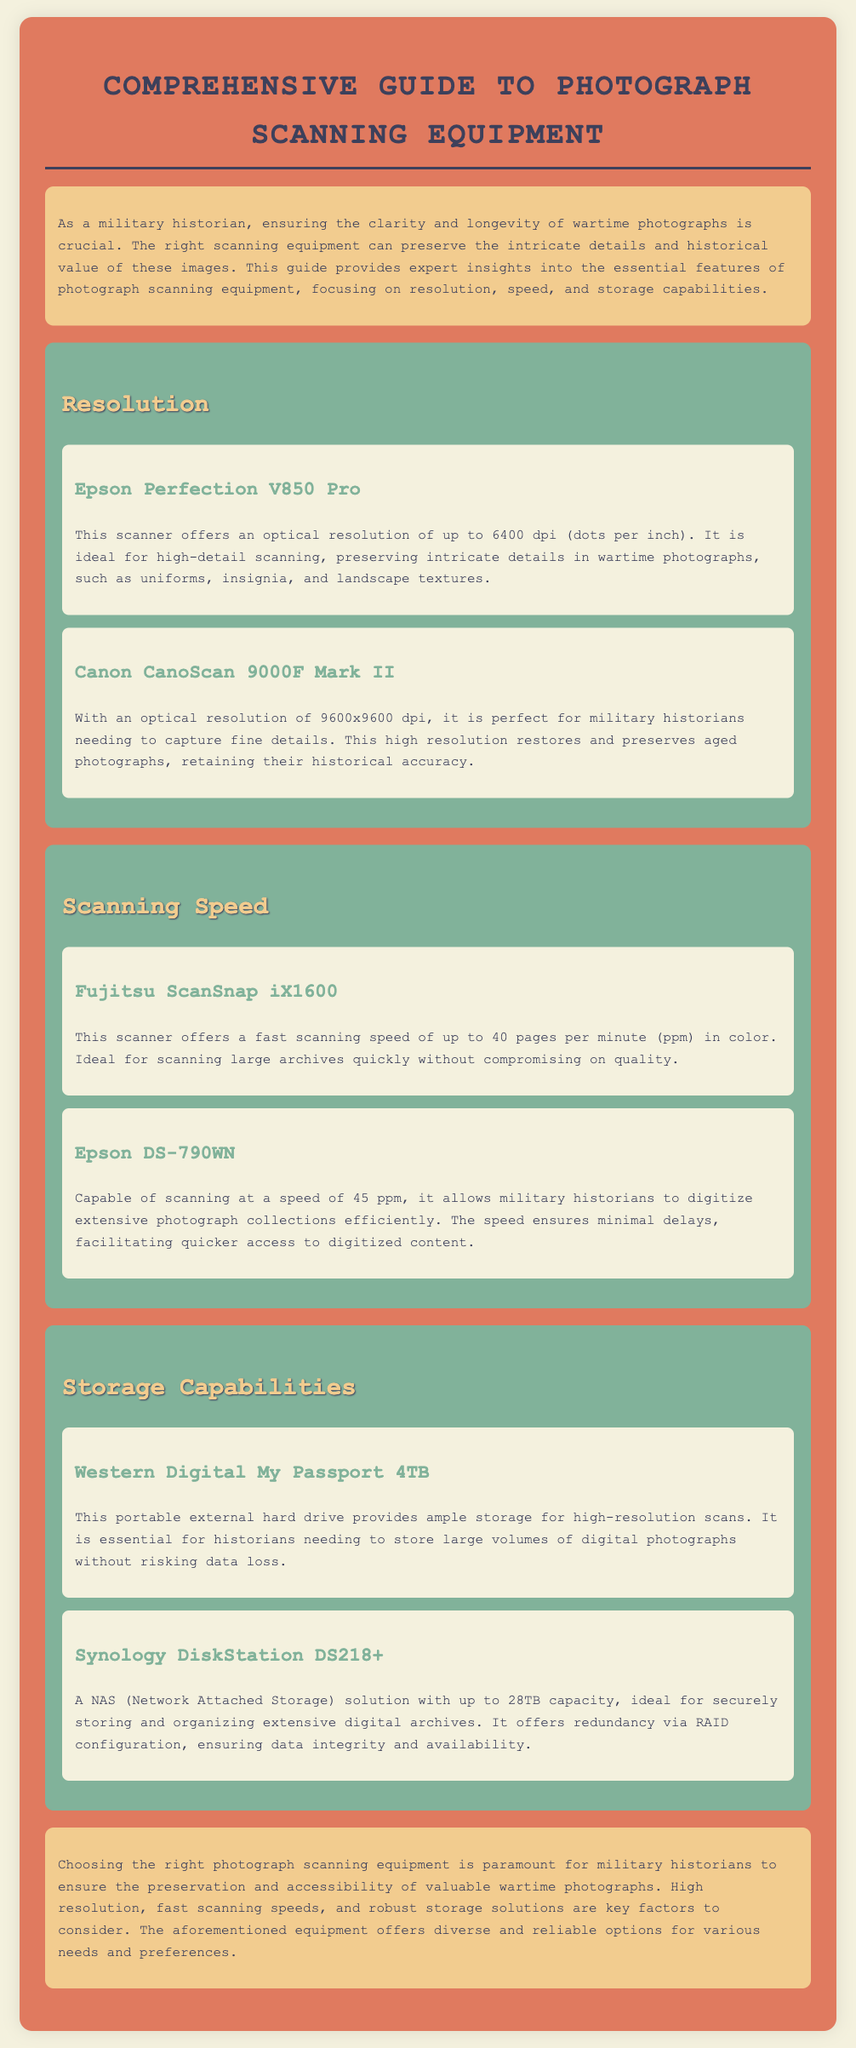What is the optical resolution of the Epson Perfection V850 Pro? The optical resolution is noted as up to 6400 dpi in the document.
Answer: 6400 dpi What is the scanning speed of the Epson DS-790WN? The document states that the Epson DS-790WN scans at a speed of 45 pages per minute.
Answer: 45 ppm Which hard drive is mentioned for storing high-resolution scans? The document lists the Western Digital My Passport 4TB as a storage solution for high-resolution scans.
Answer: Western Digital My Passport 4TB How much capacity does the Synology DiskStation DS218+ have? The document indicates that the Synology DiskStation DS218+ has up to 28TB capacity.
Answer: 28TB What is the purpose of the document? The purpose, as stated in the introduction, is to provide expert insights into photograph scanning equipment.
Answer: Expert insights on scanning equipment Which scanner offers a resolution of 9600x9600 dpi? The Canon CanoScan 9000F Mark II is mentioned in the document as having this resolution.
Answer: Canon CanoScan 9000F Mark II What is the primary focus of the guide? The primary focus of the guide is on resolution, speed, and storage capabilities of scanning equipment.
Answer: Resolution, speed, and storage capabilities What is emphasized as crucial for a military historian in the introduction? The clarity and longevity of wartime photographs are emphasized as crucial.
Answer: Clarity and longevity What type of storage solution is the Synology DiskStation DS218+ classified as? The document classifies it as a NAS (Network Attached Storage) solution.
Answer: NAS 